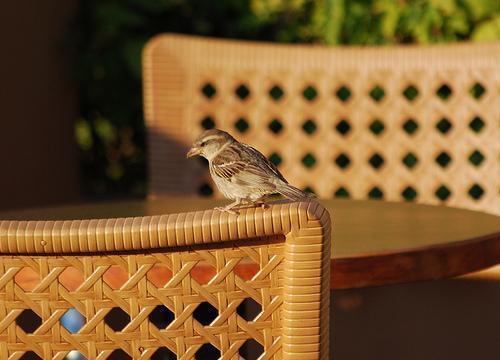How many chairs are there?
Give a very brief answer. 2. How many chairs are shown?
Give a very brief answer. 2. How many birds are shown?
Give a very brief answer. 1. 